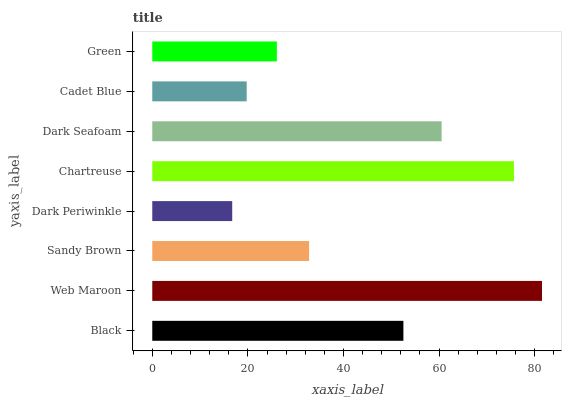Is Dark Periwinkle the minimum?
Answer yes or no. Yes. Is Web Maroon the maximum?
Answer yes or no. Yes. Is Sandy Brown the minimum?
Answer yes or no. No. Is Sandy Brown the maximum?
Answer yes or no. No. Is Web Maroon greater than Sandy Brown?
Answer yes or no. Yes. Is Sandy Brown less than Web Maroon?
Answer yes or no. Yes. Is Sandy Brown greater than Web Maroon?
Answer yes or no. No. Is Web Maroon less than Sandy Brown?
Answer yes or no. No. Is Black the high median?
Answer yes or no. Yes. Is Sandy Brown the low median?
Answer yes or no. Yes. Is Web Maroon the high median?
Answer yes or no. No. Is Black the low median?
Answer yes or no. No. 